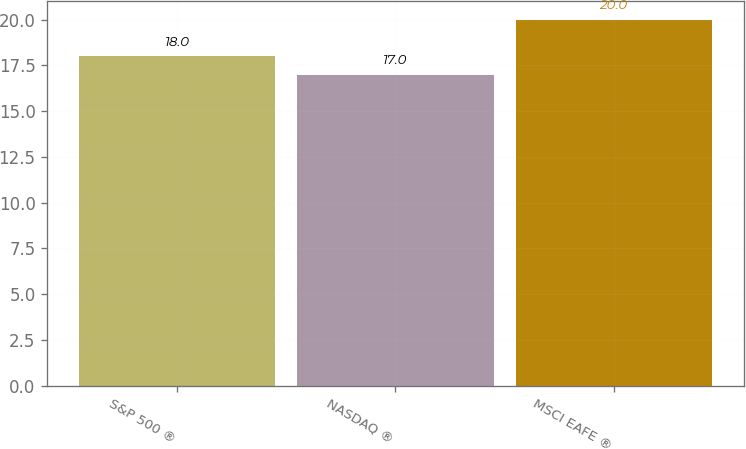Convert chart. <chart><loc_0><loc_0><loc_500><loc_500><bar_chart><fcel>S&P 500 ®<fcel>NASDAQ ®<fcel>MSCI EAFE ®<nl><fcel>18<fcel>17<fcel>20<nl></chart> 